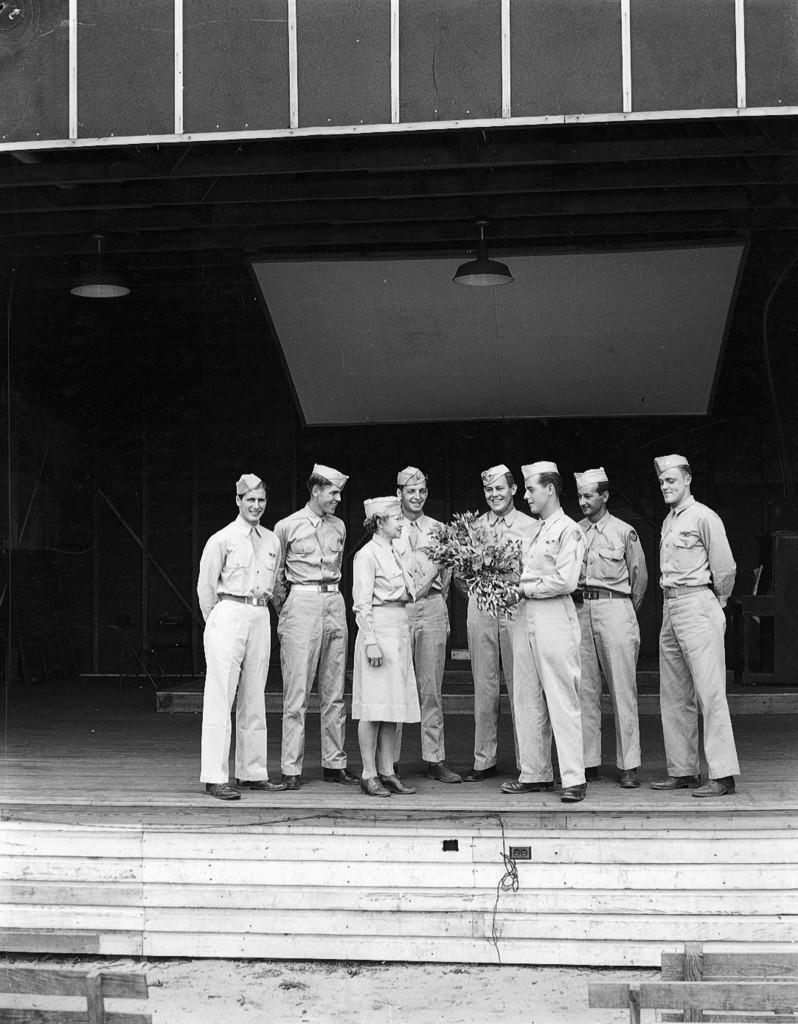How would you summarize this image in a sentence or two? In this picture there are group of people standing and there is a person standing and holding the bouquet. At the back there is a table. At the top there are lights. In the foreground there are benches. At the bottom there is mud. 